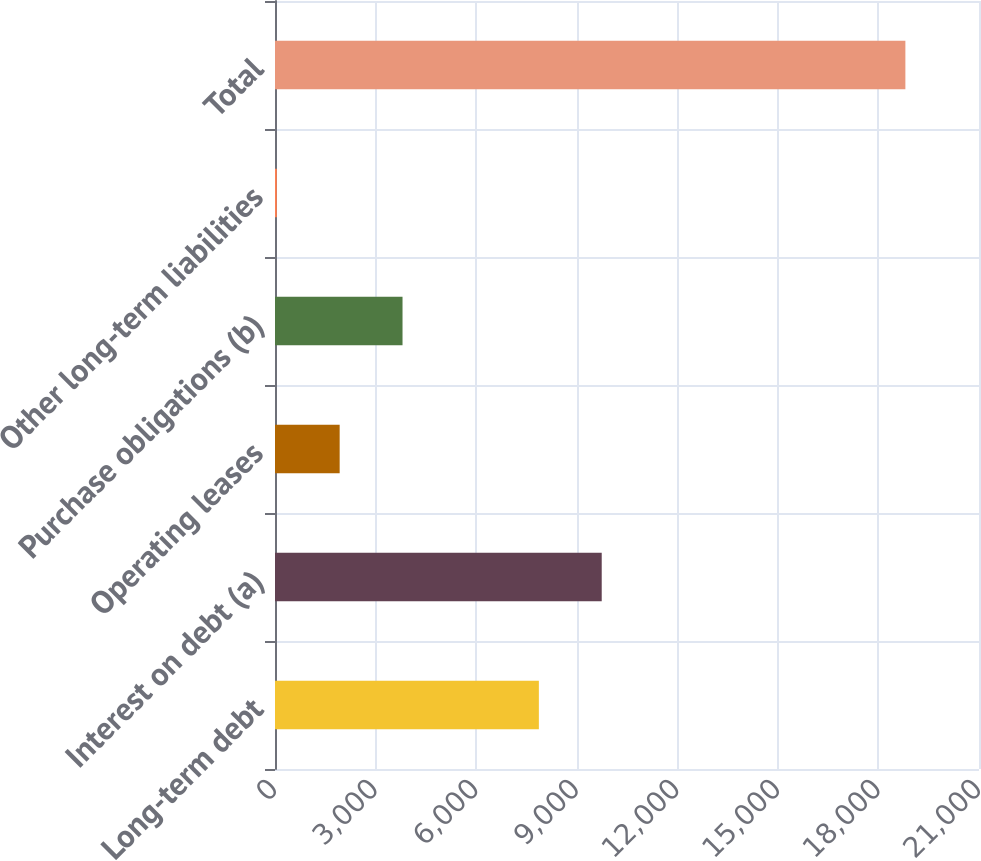Convert chart. <chart><loc_0><loc_0><loc_500><loc_500><bar_chart><fcel>Long-term debt<fcel>Interest on debt (a)<fcel>Operating leases<fcel>Purchase obligations (b)<fcel>Other long-term liabilities<fcel>Total<nl><fcel>7871<fcel>9746<fcel>1929<fcel>3804<fcel>54<fcel>18804<nl></chart> 